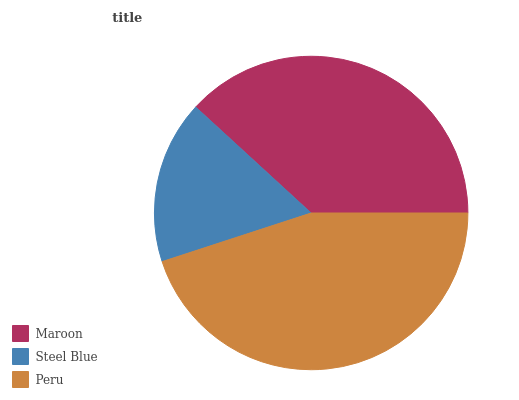Is Steel Blue the minimum?
Answer yes or no. Yes. Is Peru the maximum?
Answer yes or no. Yes. Is Peru the minimum?
Answer yes or no. No. Is Steel Blue the maximum?
Answer yes or no. No. Is Peru greater than Steel Blue?
Answer yes or no. Yes. Is Steel Blue less than Peru?
Answer yes or no. Yes. Is Steel Blue greater than Peru?
Answer yes or no. No. Is Peru less than Steel Blue?
Answer yes or no. No. Is Maroon the high median?
Answer yes or no. Yes. Is Maroon the low median?
Answer yes or no. Yes. Is Peru the high median?
Answer yes or no. No. Is Peru the low median?
Answer yes or no. No. 